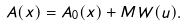Convert formula to latex. <formula><loc_0><loc_0><loc_500><loc_500>A ( x ) = A _ { 0 } ( x ) + M W ( u ) .</formula> 